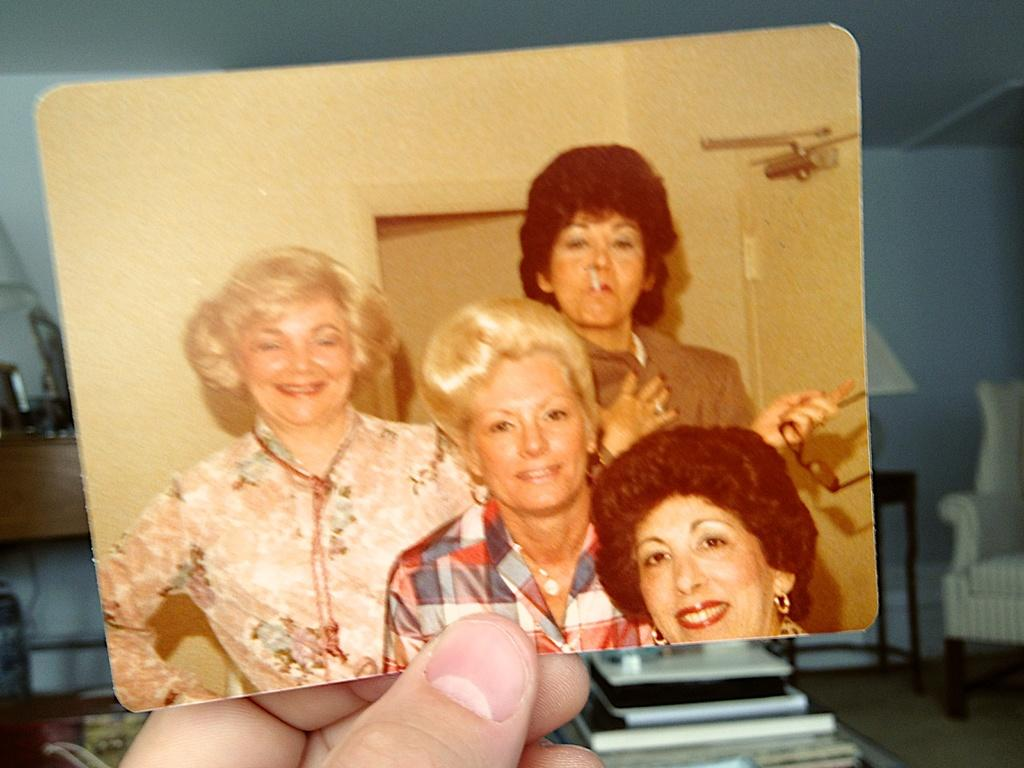What is the person holding in the image? There is a hand holding a photograph in the image. What can be seen in the photograph? The photograph contains persons. What piece of furniture is on the right side of the image? There is a couch on the right side of the image. What type of objects are at the bottom of the image? There are books at the bottom of the image. Can you hear the whistle in the image? There is no whistle present in the image. What type of jar is visible on the couch? There is no jar visible on the couch in the image. 